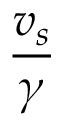Convert formula to latex. <formula><loc_0><loc_0><loc_500><loc_500>\frac { v _ { s } } { \gamma }</formula> 